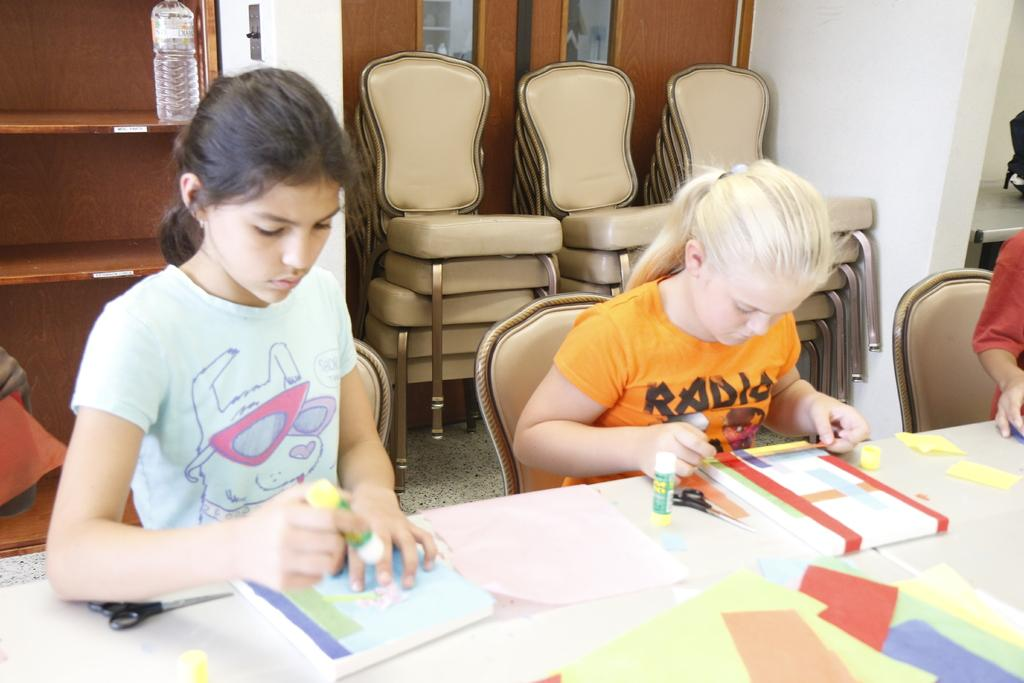How many people are in the image? There are two girls in the image. What are the girls doing in the image? The girls are sitting on a chair and doing work with books. What is in front of the girls? There is a table in front of the girls. What can be found on the table? The table has books on it. What type of yam is the girls using as a bookmark in the image? There is no yam present in the image, and the girls are not using any bookmarks. 